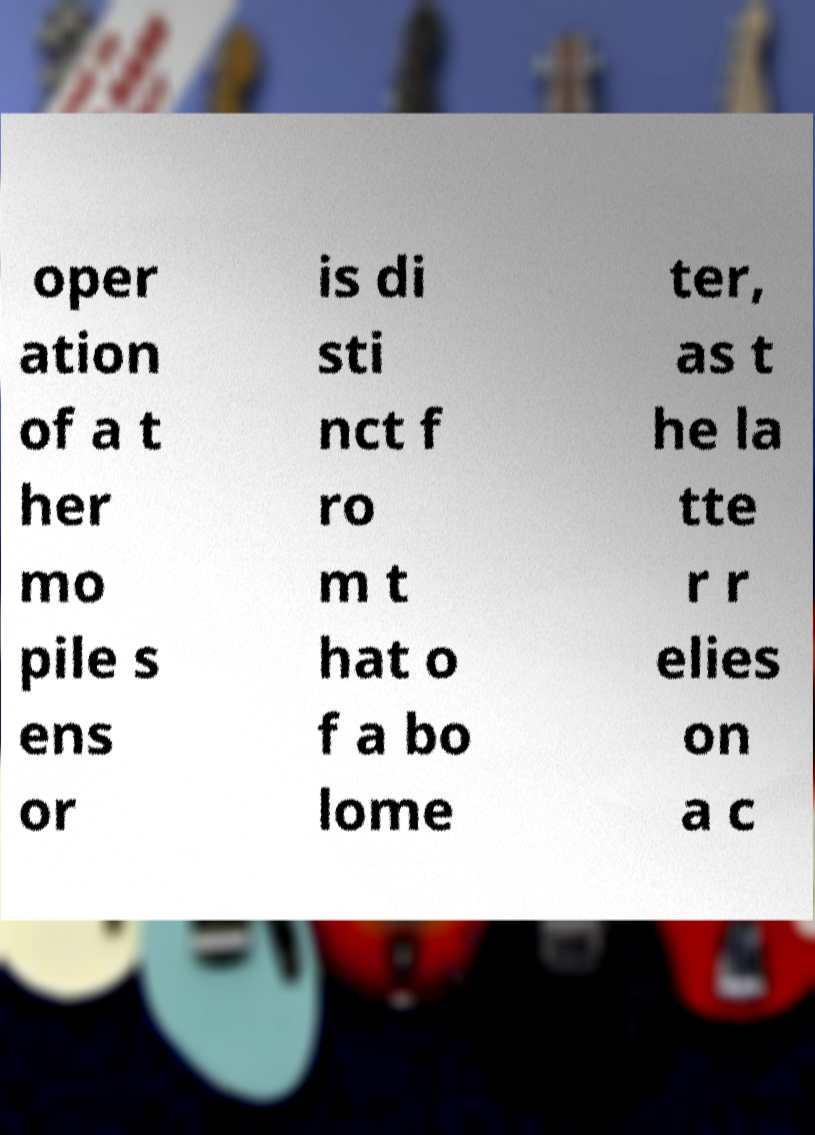Could you assist in decoding the text presented in this image and type it out clearly? oper ation of a t her mo pile s ens or is di sti nct f ro m t hat o f a bo lome ter, as t he la tte r r elies on a c 